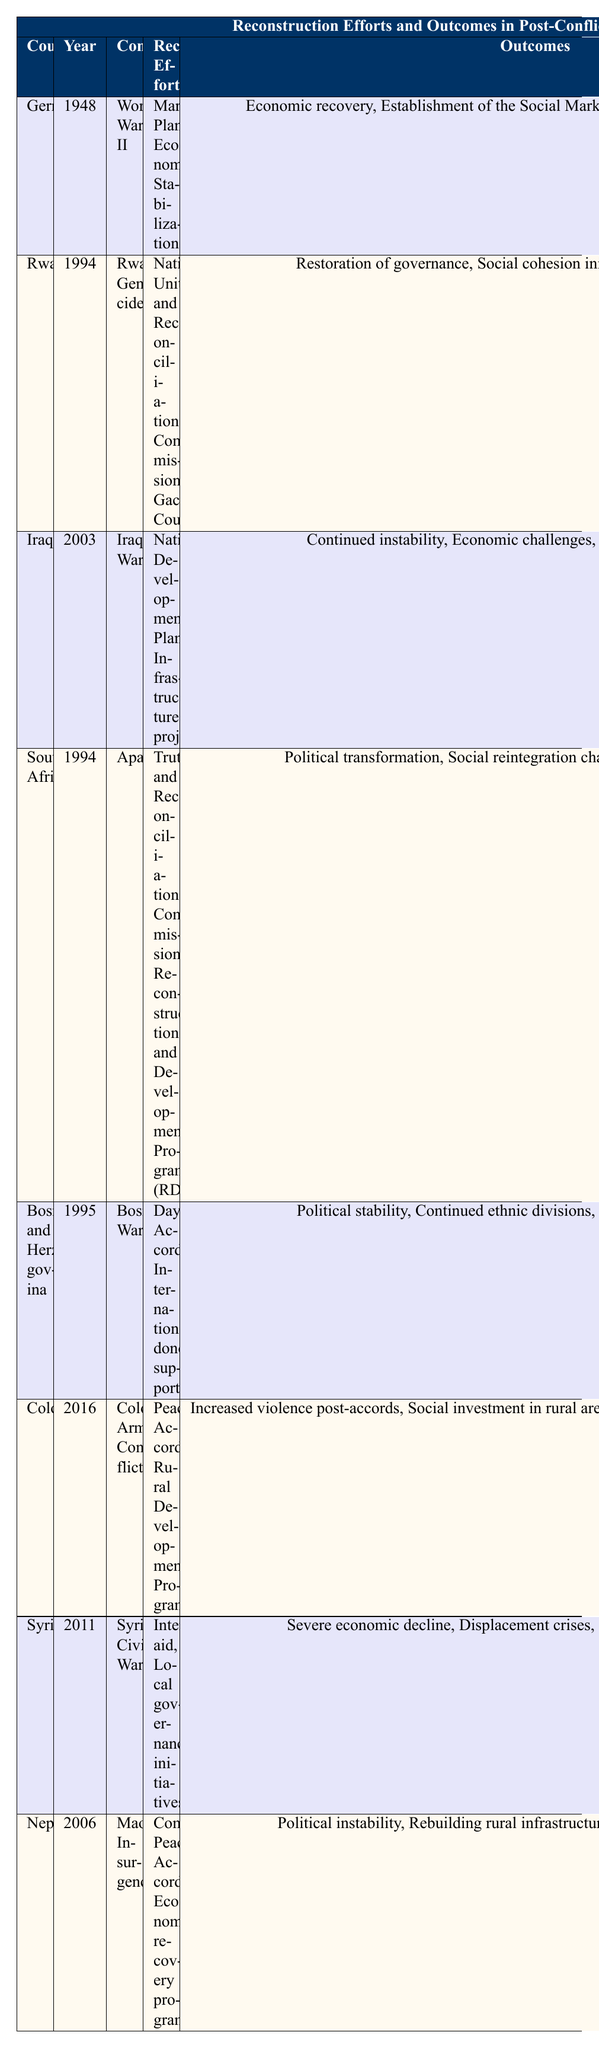What year did reconstruction efforts start in Rwanda? The table lists Rwanda under the "Country" column and shows "1994" in the "Year" column for it.
Answer: 1994 What were the reconstruction efforts for Germany after World War II? The table indicates that Germany's reconstruction efforts included the "Marshall Plan" and "Economic Stabilization" under the "Reconstruction Efforts" column.
Answer: Marshall Plan, Economic Stabilization Which conflict has been linked to ongoing violence and challenges in rural areas post-reconstruction? Looking at the table, Colombia is listed with the "Colombian Armed Conflict" and its outcomes indicate "Increased violence post-accords" and "Ongoing challenges with armed groups."
Answer: Colombian Armed Conflict Did South Africa experience economic growth as an outcome of its reconstruction efforts? The "Outcomes" column shows that South Africa faced "Economic disparity" after its reconstruction efforts, indicating that economic growth was not achieved. Therefore, the statement is false.
Answer: No Which two countries began reconstruction in the year 1994, and what conflicts were they associated with? From the table, both Rwanda and South Africa started reconstruction in 1994, with Rwanda linked to the "Rwandan Genocide" and South Africa to "Apartheid."
Answer: Rwanda (Rwandan Genocide), South Africa (Apartheid) What is the relationship between the reconstruction efforts in Syria and its economic outcomes? The table lists that Syria had "International aid" and "Local governance initiatives" as reconstruction efforts, but the outcomes were a "Severe economic decline" and "Displacement crises." This indicates that the reconstruction efforts did not lead to positive economic results.
Answer: Negative relationship Identify the nation with the earliest reconstruction efforts and describe the outcomes. The table shows Germany started its reconstruction in 1948, with outcomes such as "Economic recovery," "Establishment of the Social Market Economy," and "European Integration."
Answer: Germany; Economic recovery, Social Market Economy, European Integration List all the conflicts associated with reconstruction efforts that had challenges related to political instability. The table notes Iraq (2003), South Africa (1994), Nepal (2006) as having outcomes related to political instability.
Answer: Iraq, South Africa, Nepal Which country had reconstruction efforts starting in 2006, and what were its outcomes? The table shows Nepal began reconstruction in 2006, with outcomes of "Political instability," "Rebuilding rural infrastructure," and "Increased development aid."
Answer: Nepal; Political instability, rural infrastructure rebuilding, increased development aid What is the average start year of the reconstruction efforts listed in the table? The start years are: 1948, 1994, 2003, 1994, 1995, 2016, 2011, and 2006. If we total them (1948 + 1994 + 2003 + 1994 + 1995 + 2016 + 2011 + 2006) = 15967, then divide by 8 (number of countries): 15967 / 8 = 1995.875. Rounding gives an average start year of approximately 1996.
Answer: Approximately 1996 